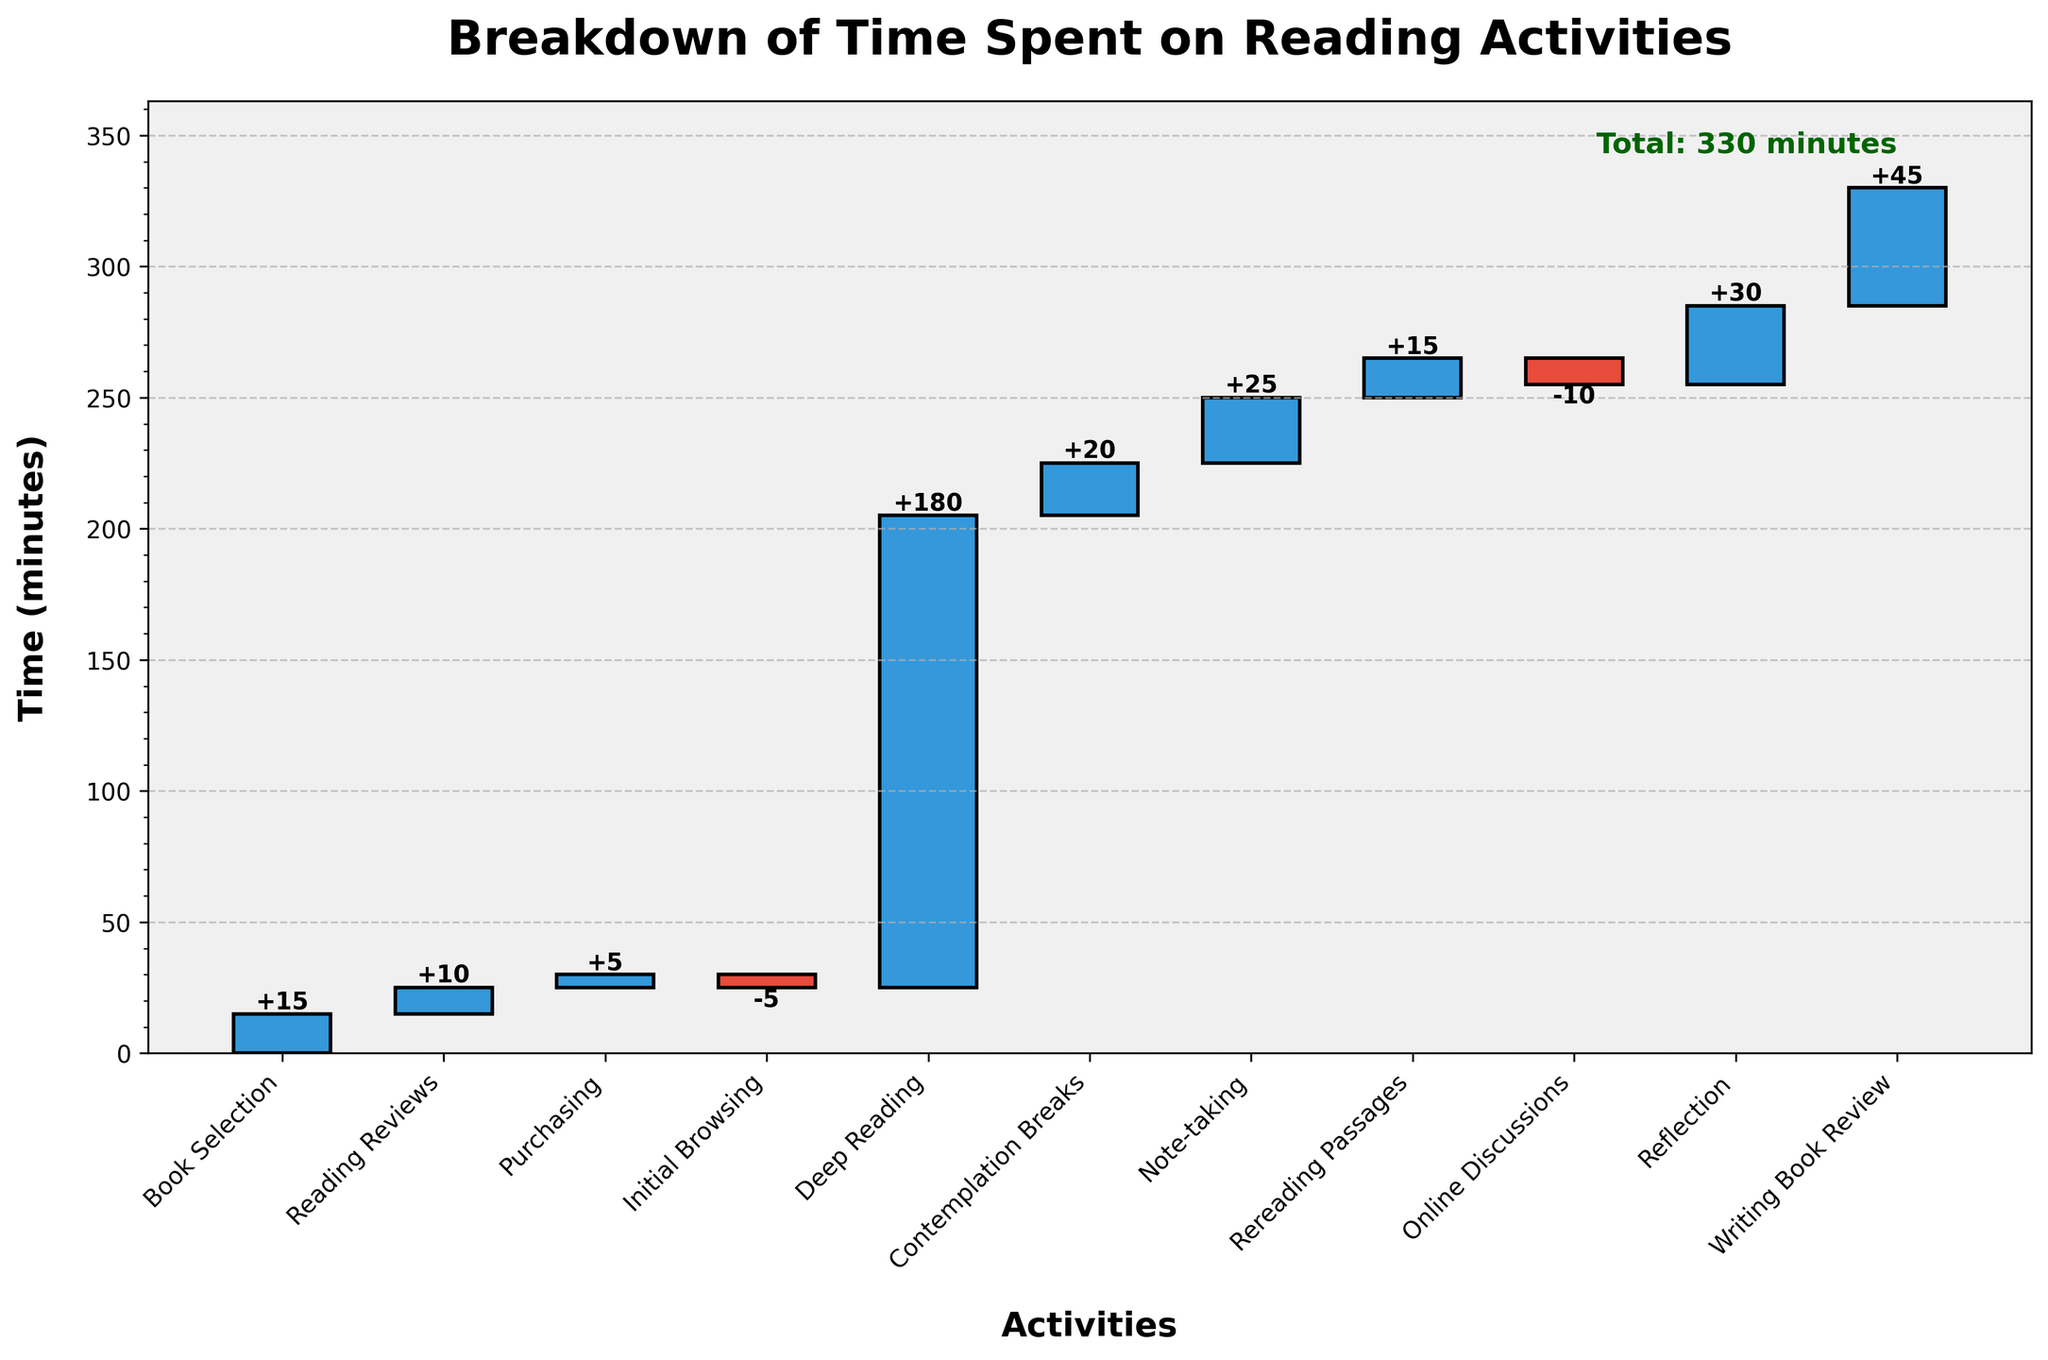What's the total time spent on reading activities? The total time is explicitly mentioned in the figure. Sum the times of all the activities to get the total time.
Answer: 330 minutes What is the title of the bar chart? The title of the chart can be found at the top of the figure
Answer: Breakdown of Time Spent on Reading Activities How much time is spent on contemplation breaks? Look for the "Contemplation Breaks" label on the x-axis and identify its corresponding bar's value.
Answer: 20 minutes Which activity takes the most amount of time? Identify the bar with the greatest height along the positive y-axis and check its corresponding x-axis label.
Answer: Deep Reading What are the two activities where time is subtracted? Look for bars with negative values on the y-axis and identify their x-axis labels.
Answer: Initial Browsing, Online Discussions How does the time spent on note-taking compare to the time spent on rereading passages? Find the values for Note-taking and Rereading Passages, then compare them directly.
Answer: 25 minutes vs. 15 minutes (Note-taking takes 10 minutes more) How much time is spent in activities after Deep Reading? Sum the times of all activities listed after the Deep Reading bar on the x-axis.
Answer: 125 minutes What's the net effect of time spent on Purchasing and Online Discussions combined? Combine the values for Purchasing and Online Discussions.
Answer: -5 minutes How much longer is the Writing Book Review step compared to Reading Reviews? Subtract the time for Reading Reviews from the time for Writing Book Review.
Answer: 35 minutes What is the cumulative time after Contemplation Breaks? Add the times of all activities up to and including Contemplation Breaks.
Answer: 245 minutes 